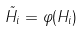<formula> <loc_0><loc_0><loc_500><loc_500>\tilde { H _ { i } } = \varphi ( H _ { i } )</formula> 